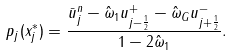Convert formula to latex. <formula><loc_0><loc_0><loc_500><loc_500>p _ { j } ( x _ { j } ^ { * } ) = \frac { \bar { u } _ { j } ^ { n } - \hat { \omega } _ { 1 } u _ { j - \frac { 1 } { 2 } } ^ { + } - \hat { \omega } _ { G } u _ { j + \frac { 1 } { 2 } } ^ { - } } { 1 - 2 \hat { \omega } _ { 1 } } .</formula> 